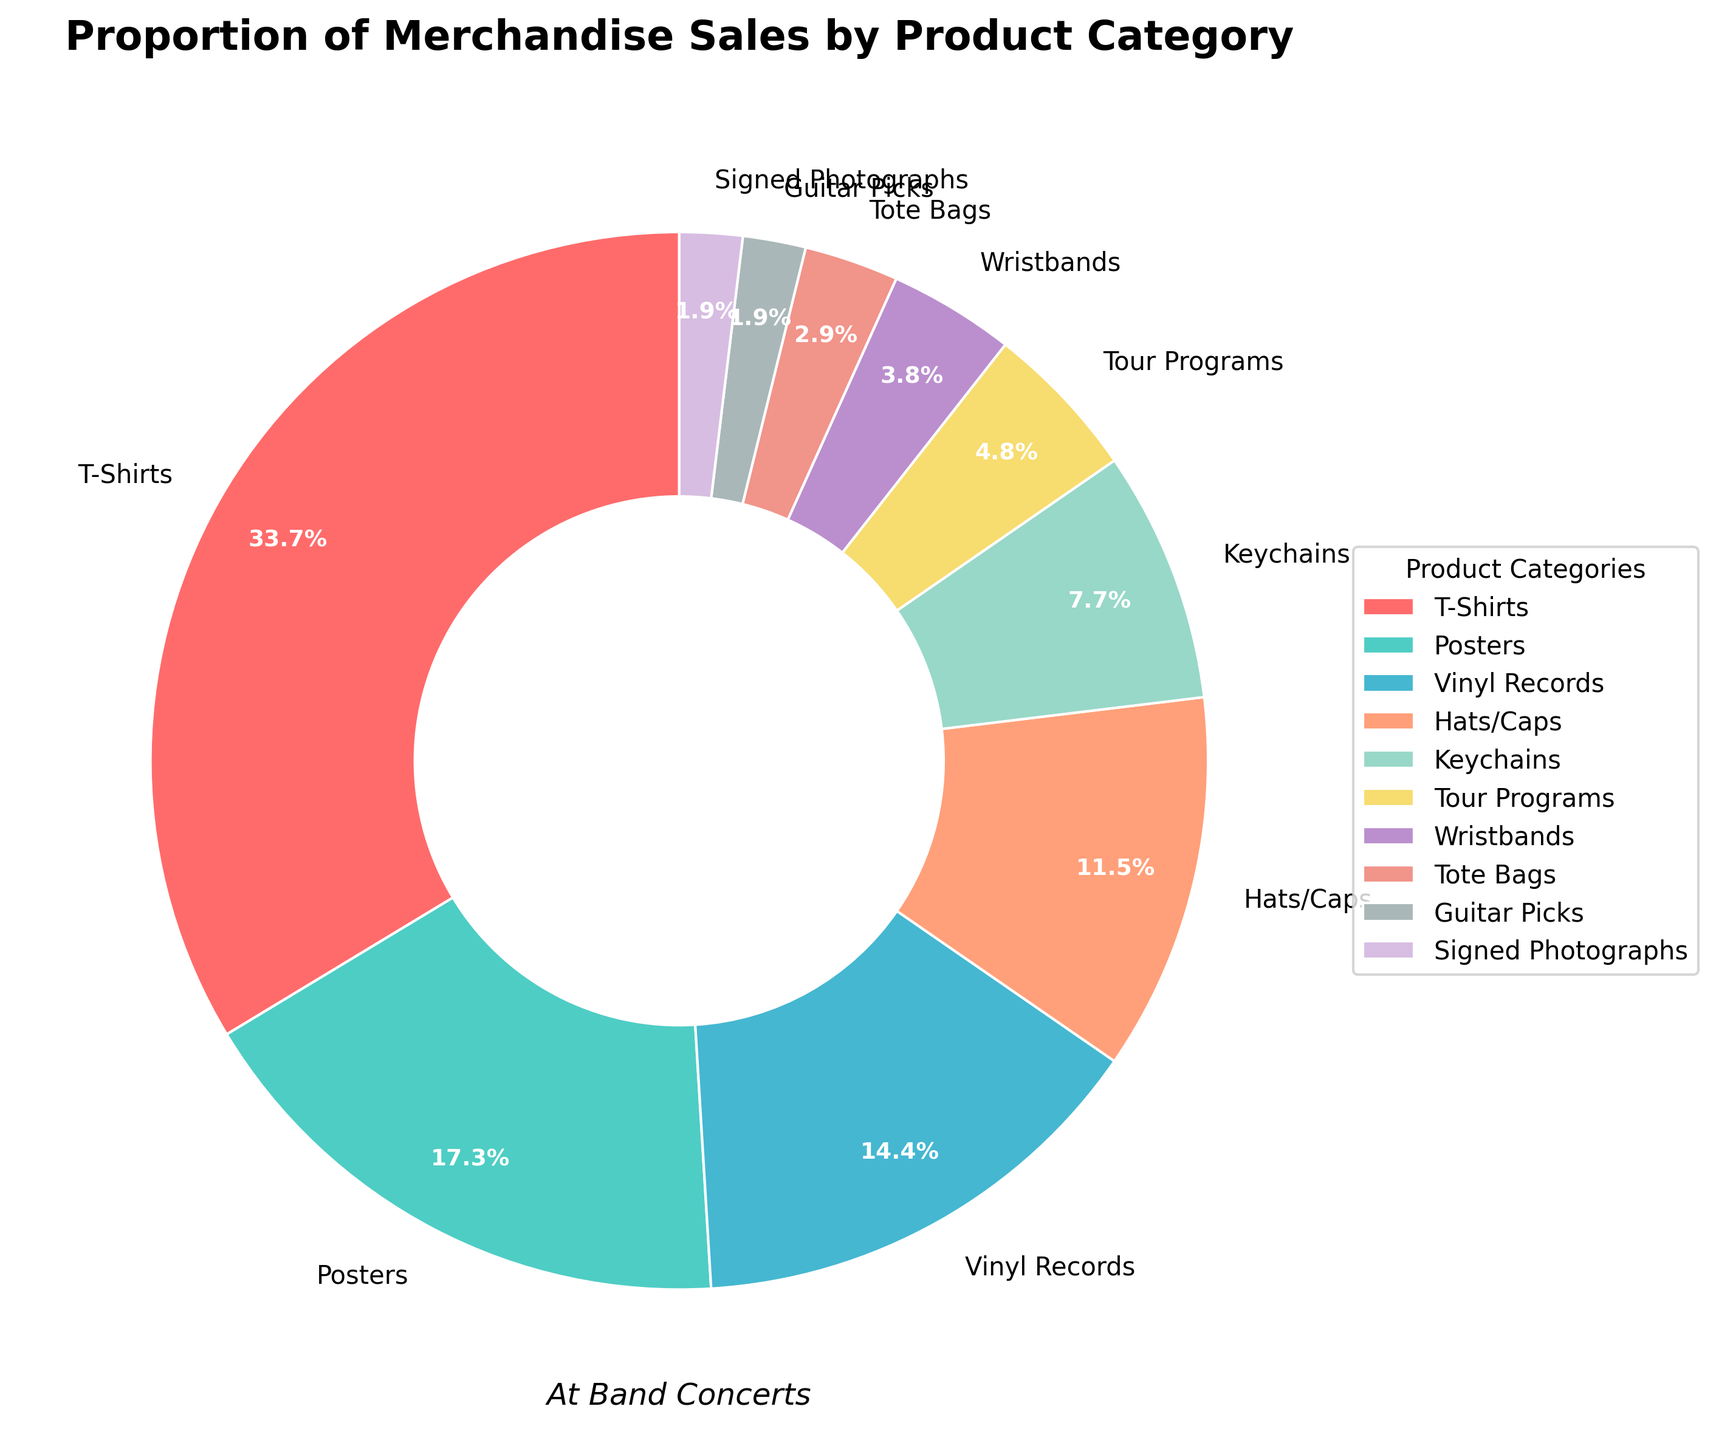What's the percentage of total merchandise sales that comes from T-Shirts and Posters combined? To get the combined percentage, add the percentages of T-Shirts and Posters: 35% + 18% = 53%
Answer: 53% Which product category contributes the least to the merchandise sales? The category with the smallest percentage is the one contributing the least. From the chart, Guitar Picks and Signed Photographs both contribute 2%.
Answer: Guitar Picks and Signed Photographs What is the difference in sales percentage between T-Shirts and Vinyl Records? Subtract the percentage of Vinyl Records from the percentage of T-Shirts: 35% - 15% = 20%
Answer: 20% Are the sales from Hats/Caps greater than those from Keychains and Wristbands combined? First, calculate the combined percentage of Keychains and Wristbands: 8% + 4% = 12%. Then compare it with Hats/Caps: 12% < 12%.
Answer: No What is the visually dominant color in the pie chart? The visually dominant color refers to the category with the largest slice, which is T-Shirts with 35%. The color of T-Shirts is red.
Answer: Red Which category has similar sales percentages to Posters, and what is the percentage difference between them? The categories with percentages near Posters (18%) are Vinyl Records (15%) and Hats/Caps (12%). The differences are 18% - 15% = 3% for Vinyl Records and 18% - 12% = 6% for Hats/Caps. The smaller difference is with Vinyl Records.
Answer: Vinyl Records, 3% Are the combined sales percentages of Tote Bags and Tour Programs more or less than the sales percentage of Posters? First, sum up the percentages of Tote Bags and Tour Programs: 3% + 5% = 8%. Then compare it with Posters: 8% < 18%.
Answer: Less What is the total percentage of sales for items other than T-Shirts and Posters? First, sum up the percentages of all other categories: 15% (Vinyl Records) + 12% (Hats/Caps) + 8% (Keychains) + 5% (Tour Programs) + 4% (Wristbands) + 3% (Tote Bags) + 2% (Guitar Picks) + 2% (Signed Photographs) = 51%
Answer: 51% Out of Keychains and Tour Programs, which category has a higher percentage of sales? The category with the higher percentage between Keychains (8%) and Tour Programs (5%) is Keychains.
Answer: Keychains How does the percentage of Wristbands compare to Guitar Picks in merchandise sales? Compare Wristbands (4%) to Guitar Picks (2%): 4% > 2%
Answer: Wristbands are higher In terms of merchandise sales, are Vinyl Records selling more than Hats/Caps and Wristbands combined? Calculate the combined percentage of Hats/Caps and Wristbands: 12% + 4% = 16%. Compare it with Vinyl Records (15%): 15% < 16%.
Answer: No 